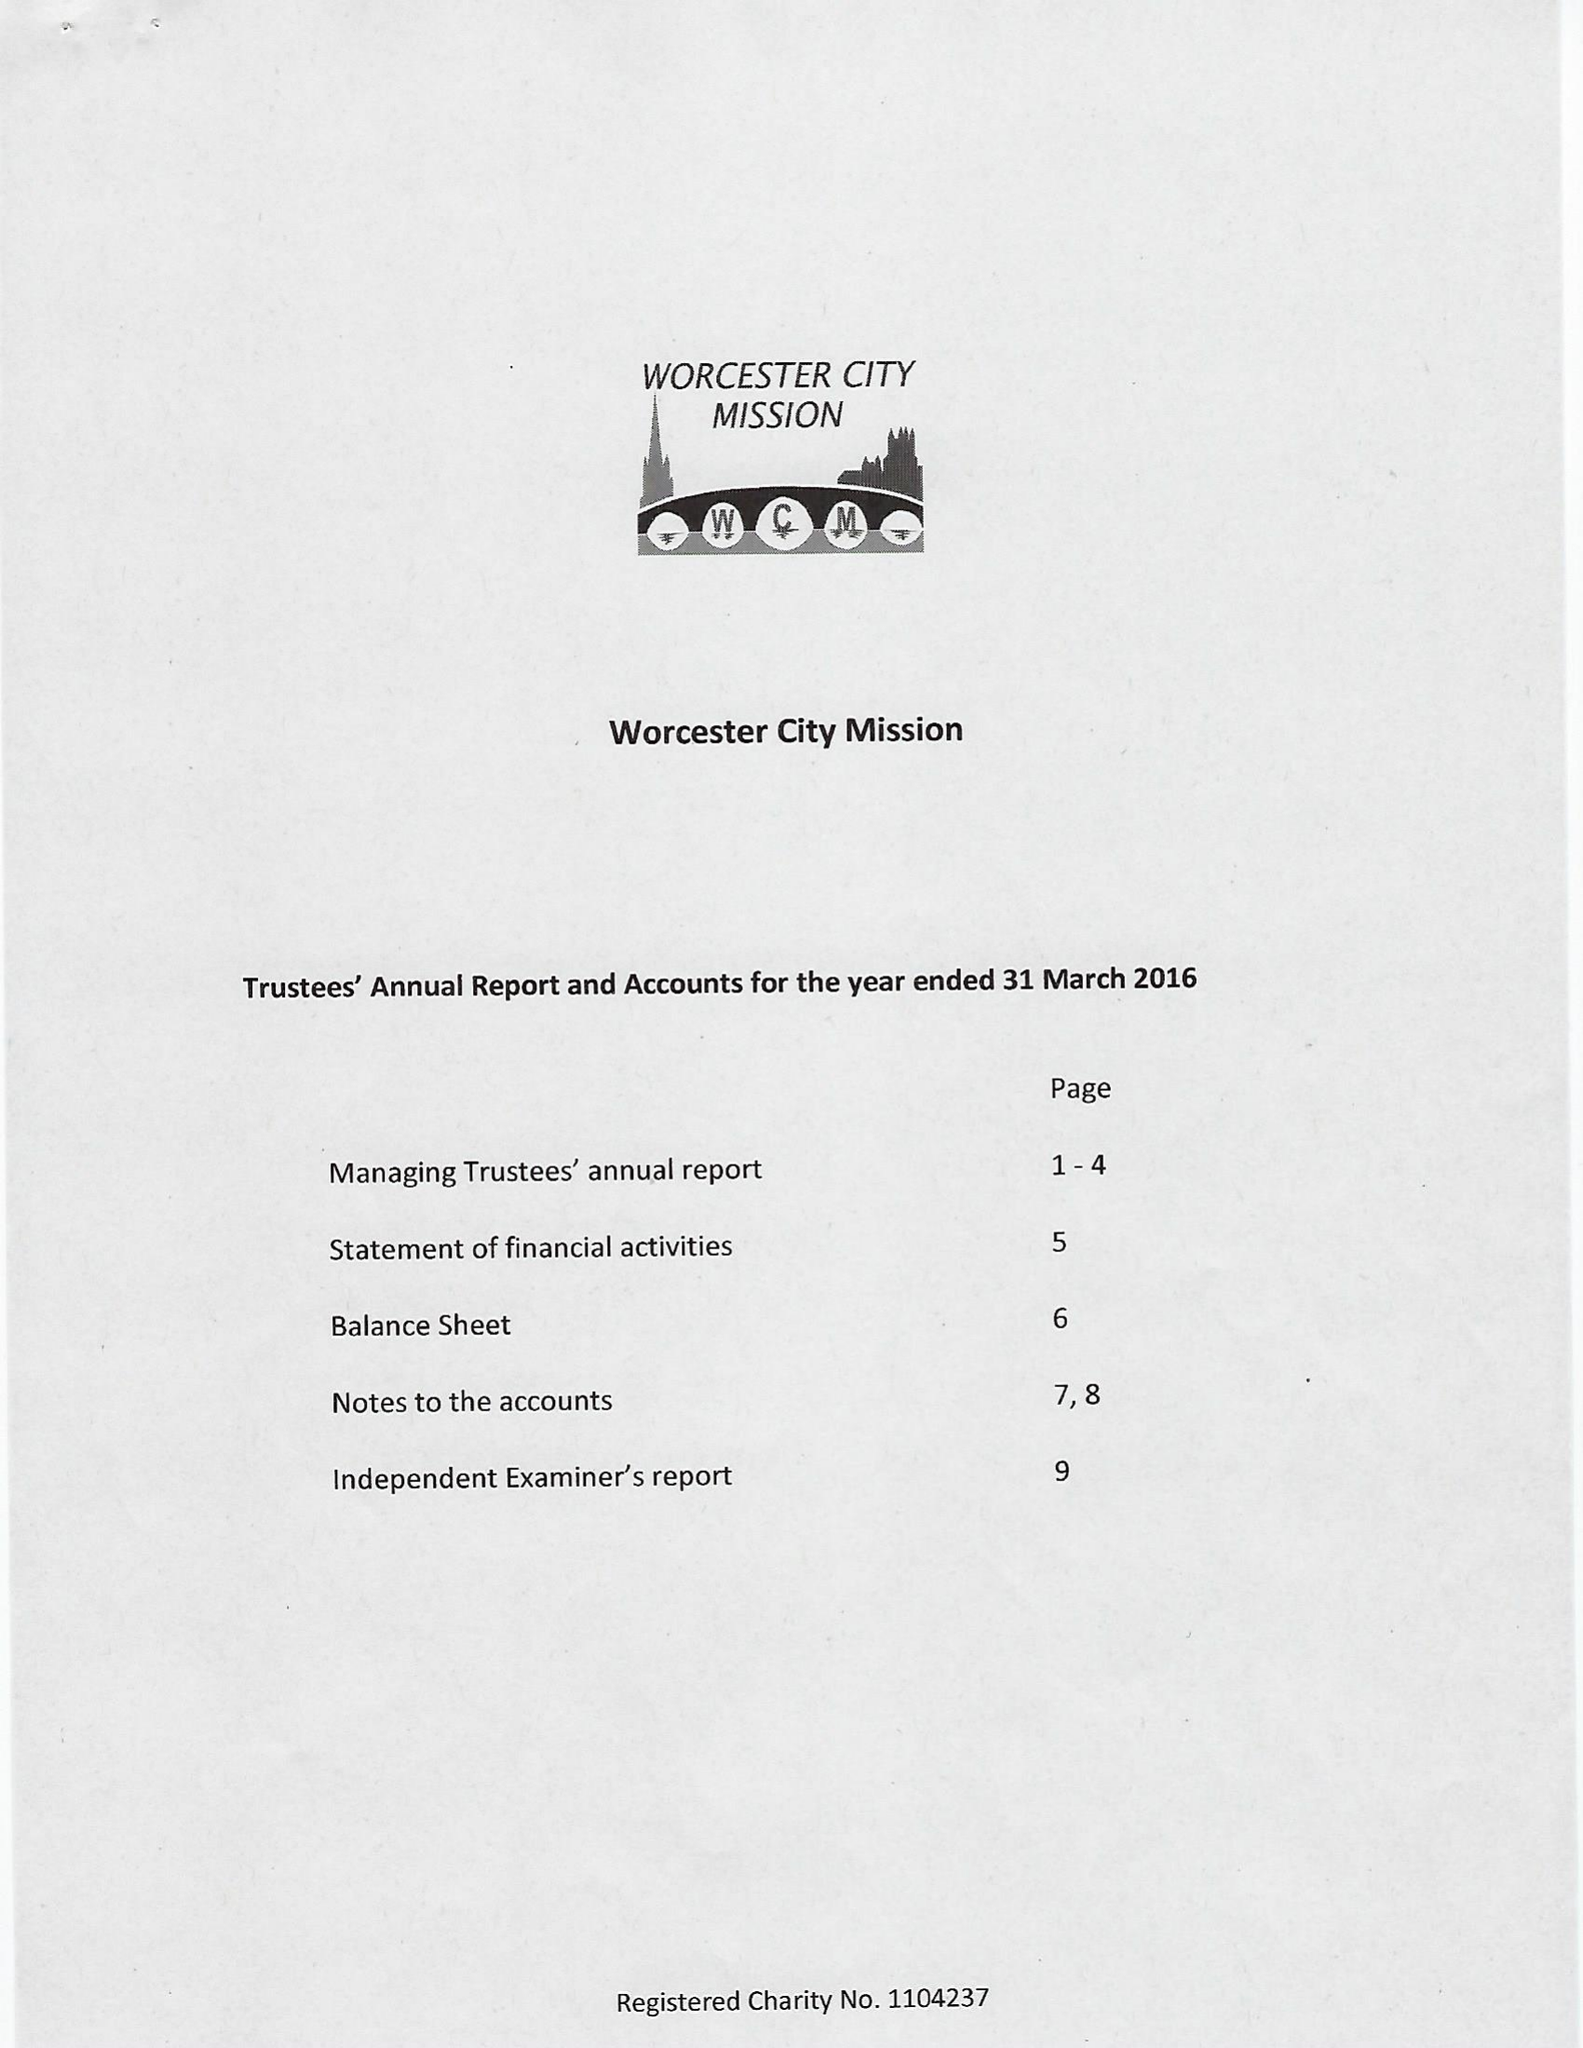What is the value for the address__street_line?
Answer the question using a single word or phrase. 8 OAKLEIGH AVENUE 